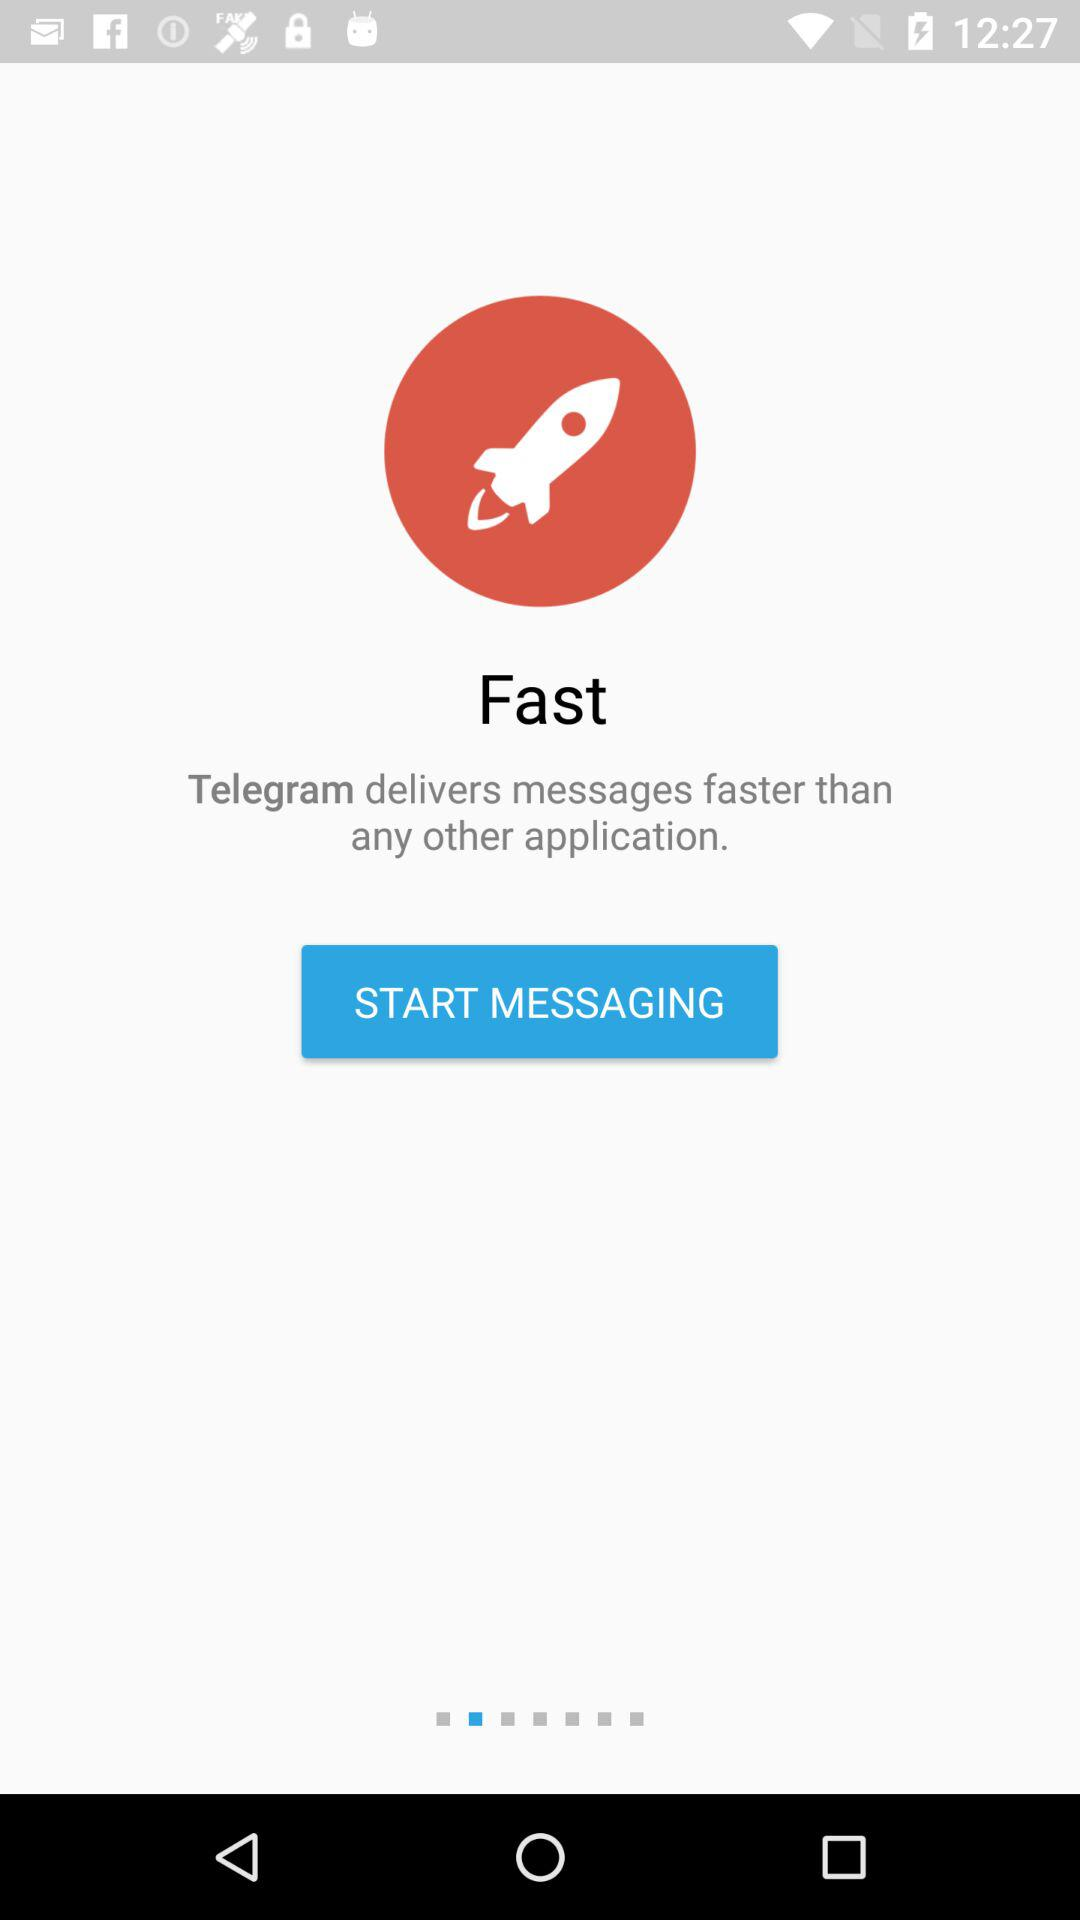What is the application name? The application name is "Telegram". 